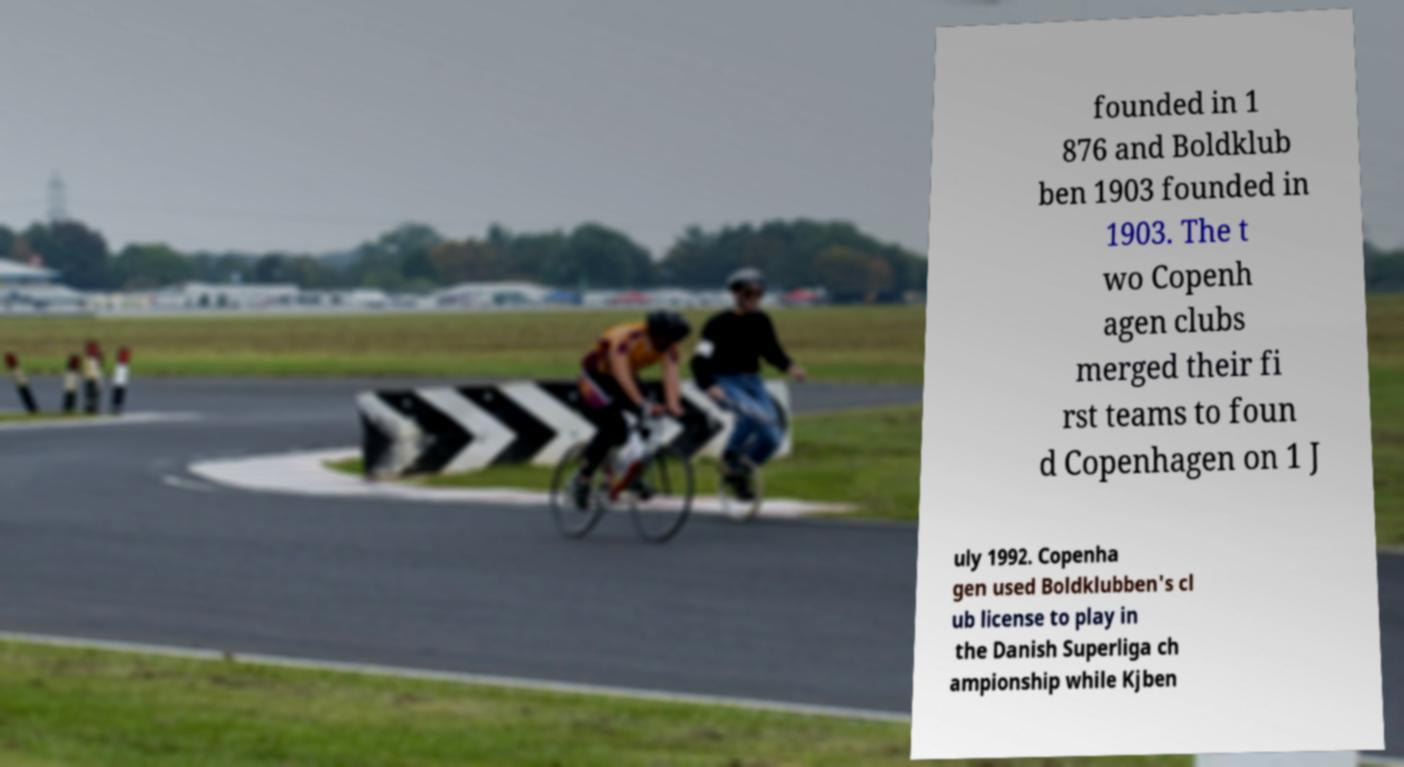What messages or text are displayed in this image? I need them in a readable, typed format. founded in 1 876 and Boldklub ben 1903 founded in 1903. The t wo Copenh agen clubs merged their fi rst teams to foun d Copenhagen on 1 J uly 1992. Copenha gen used Boldklubben's cl ub license to play in the Danish Superliga ch ampionship while Kjben 